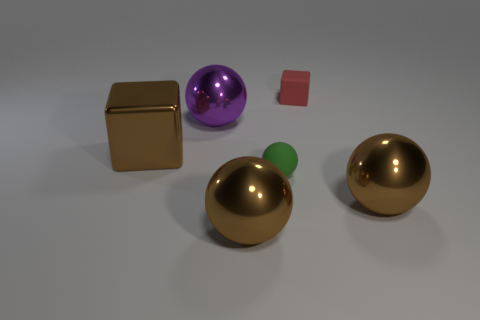There is a purple metallic thing that is the same size as the shiny block; what shape is it?
Ensure brevity in your answer.  Sphere. Is there a big sphere of the same color as the big block?
Provide a succinct answer. Yes. Do the big purple shiny thing and the red object have the same shape?
Your answer should be very brief. No. How many large objects are red blocks or green balls?
Ensure brevity in your answer.  0. What is the color of the small cube that is the same material as the green ball?
Your response must be concise. Red. How many tiny green balls are the same material as the red object?
Your answer should be compact. 1. There is a brown metal object to the right of the matte block; is it the same size as the block on the left side of the small cube?
Provide a short and direct response. Yes. What is the material of the green ball in front of the object that is behind the big purple sphere?
Give a very brief answer. Rubber. Are there fewer small red cubes right of the red rubber block than objects on the right side of the green object?
Make the answer very short. Yes. Is there any other thing that is the same shape as the purple shiny thing?
Provide a short and direct response. Yes. 